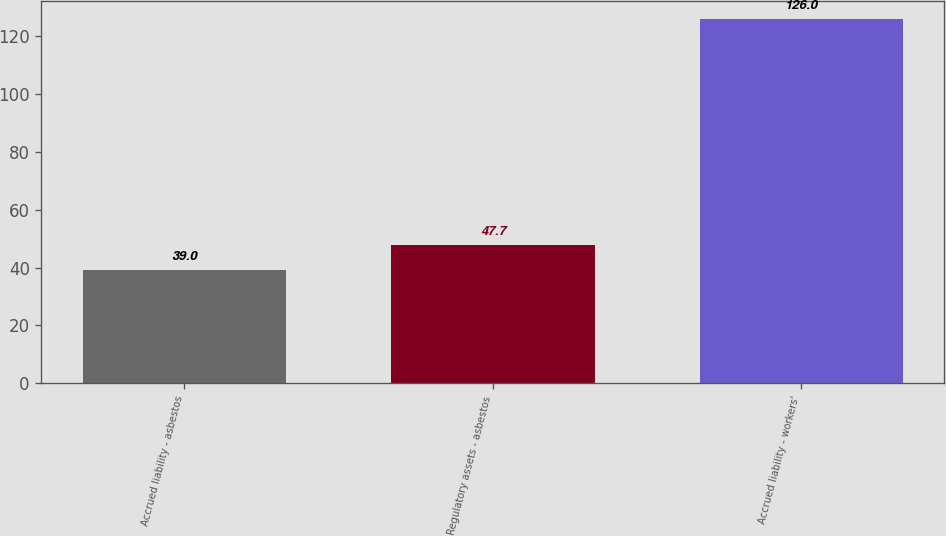<chart> <loc_0><loc_0><loc_500><loc_500><bar_chart><fcel>Accrued liability - asbestos<fcel>Regulatory assets - asbestos<fcel>Accrued liability - workers'<nl><fcel>39<fcel>47.7<fcel>126<nl></chart> 